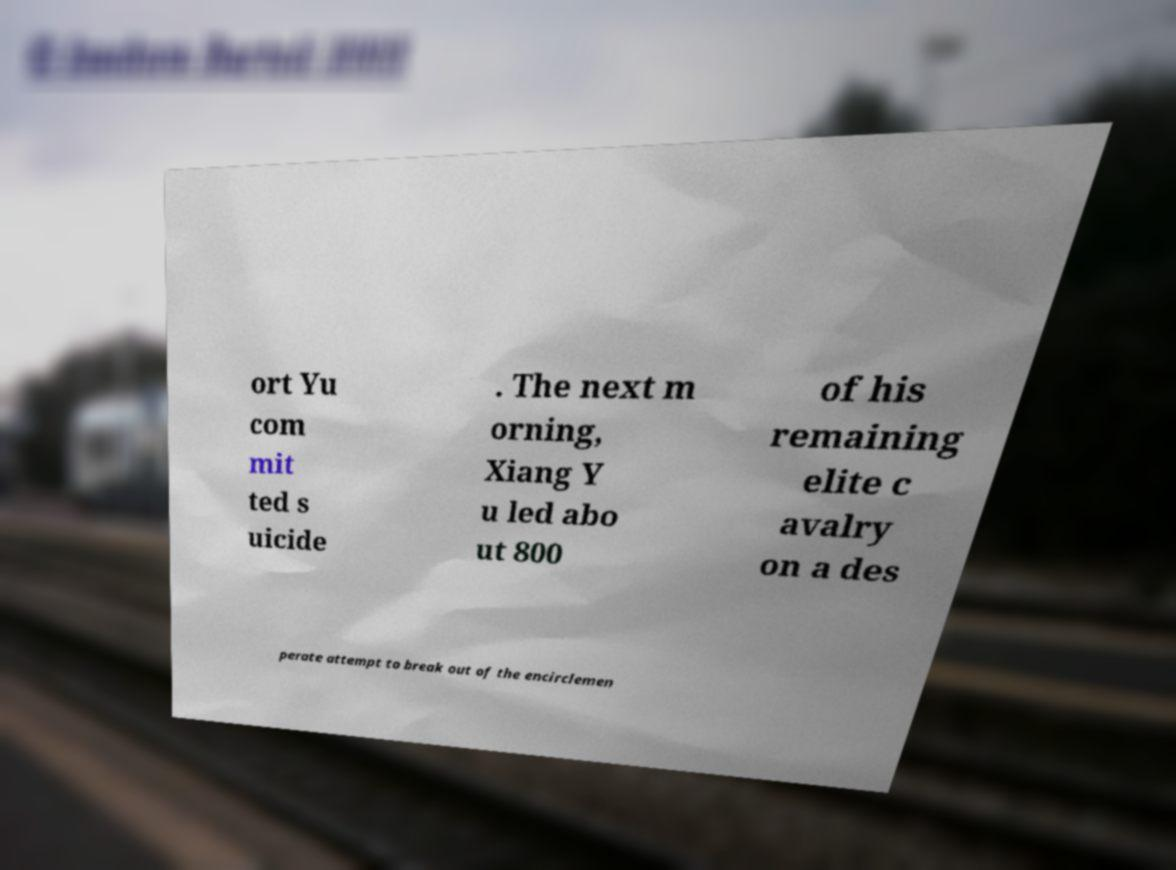Could you extract and type out the text from this image? ort Yu com mit ted s uicide . The next m orning, Xiang Y u led abo ut 800 of his remaining elite c avalry on a des perate attempt to break out of the encirclemen 